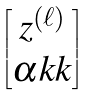Convert formula to latex. <formula><loc_0><loc_0><loc_500><loc_500>\begin{bmatrix} z ^ { ( \ell ) } \\ \alpha k k \end{bmatrix}</formula> 